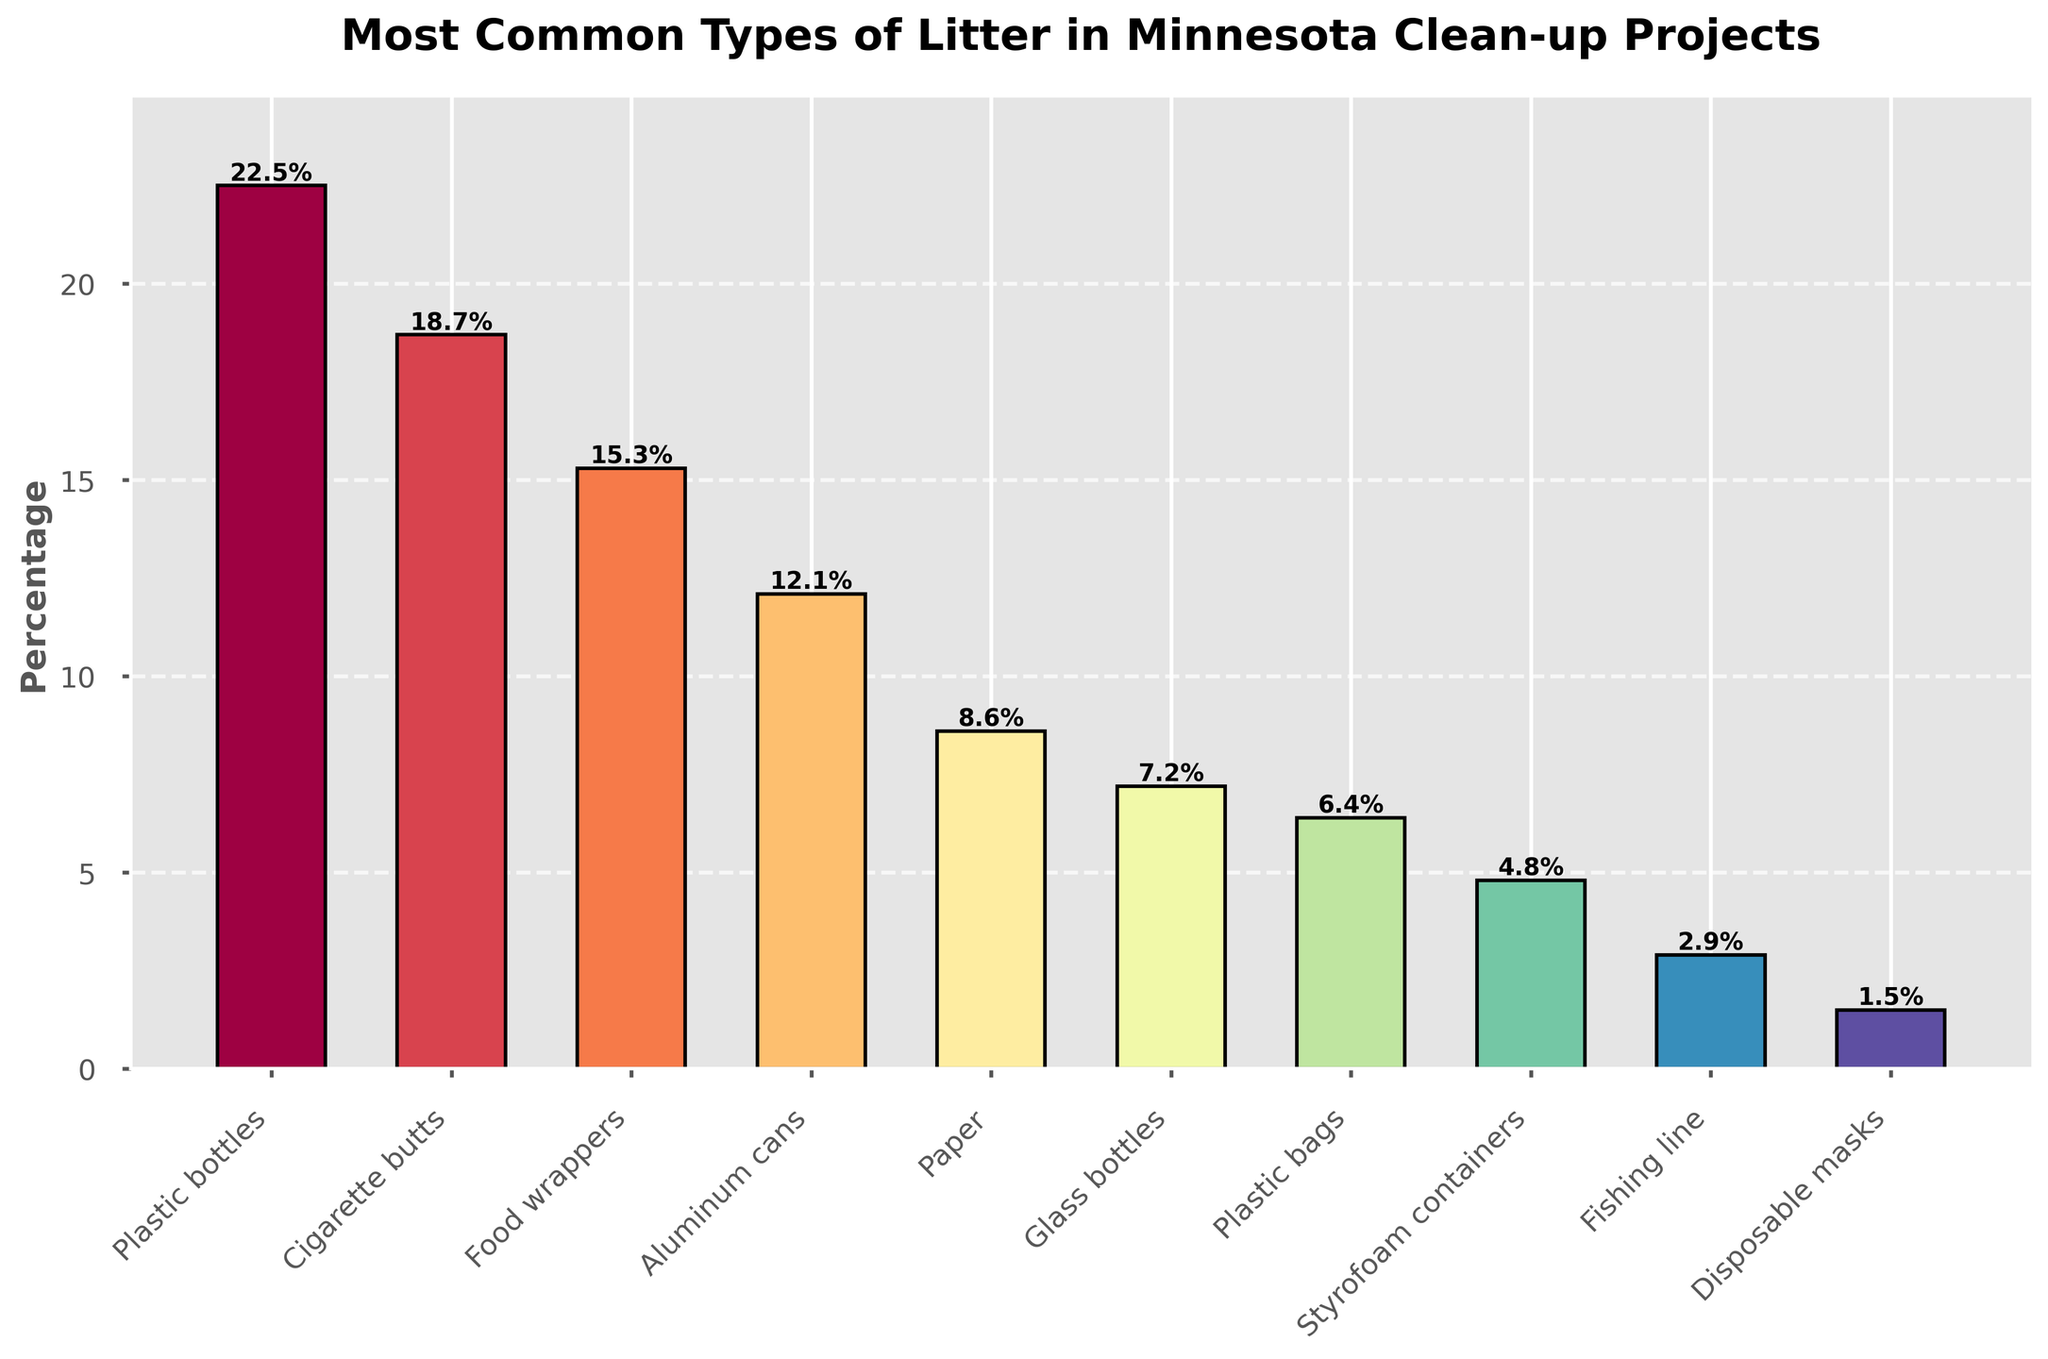Which material has the highest percentage of litter collected? By examining the height of the bars, it can be observed that the bar for Plastic bottles is the tallest, indicating the highest percentage.
Answer: Plastic bottles Which two materials have the closest percentage of litter collected? By comparing the heights of the bars, it is apparent that Glass bottles (7.2%) and Plastic bags (6.4%) have the closest percentages.
Answer: Glass bottles and Plastic bags What is the total percentage of the top three most common types of litter? Summing up the percentages of Plastic bottles (22.5%), Cigarette butts (18.7%), and Food wrappers (15.3%) gives 22.5 + 18.7 + 15.3 = 56.5%.
Answer: 56.5% How many materials have a litter percentage below 10%? By examining the bars lower than the 10% mark, it is clear that the materials are Paper, Glass bottles, Plastic bags, Styrofoam containers, Fishing line, and Disposable masks, totaling 6 materials.
Answer: 6 Which type of material accounts for less litter: Aluminum cans or Styrofoam containers? By comparing the heights of the bars, Aluminum cans (12.1%) are higher than Styrofoam containers (4.8%), indicating that Styrofoam containers account for less litter.
Answer: Styrofoam containers What is the difference in the percentage of litter between Paper and Plastic bottles? The percentage for Plastic bottles (22.5%) minus the percentage for Paper (8.6%) gives 22.5 - 8.6 = 13.9%.
Answer: 13.9% Which material ranks fifth in terms of percentage of litter collected? By ordering the bars from highest to lowest, the fifth material is Paper with 8.6%.
Answer: Paper What is the combined percentage of litter for the least common three materials? Summing the percentages of Fishing line (2.9%), Disposable masks (1.5%), and Styrofoam containers (4.8%) gives 2.9 + 1.5 + 4.8 = 9.2%.
Answer: 9.2% What is the average percentage of litter for Glass bottles and Aluminum cans? The sum of the percentages of Glass bottles (7.2%) and Aluminum cans (12.1%) is 7.2 + 12.1 = 19.3%. Dividing by 2 gives 19.3 / 2 = 9.65%.
Answer: 9.65% How much more common is Plastic bottles litter compared to Plastic bags litter? The percentage of Plastic bottles (22.5%) minus the percentage of Plastic bags (6.4%) gives 22.5 - 6.4 = 16.1%.
Answer: 16.1% 